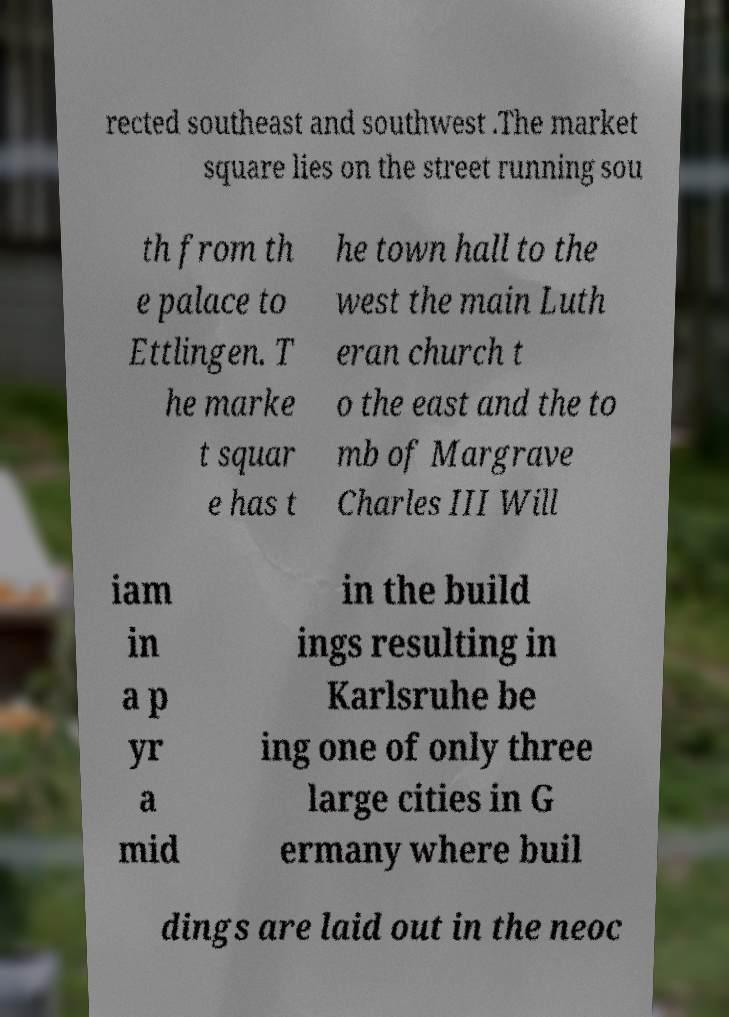Please read and relay the text visible in this image. What does it say? rected southeast and southwest .The market square lies on the street running sou th from th e palace to Ettlingen. T he marke t squar e has t he town hall to the west the main Luth eran church t o the east and the to mb of Margrave Charles III Will iam in a p yr a mid in the build ings resulting in Karlsruhe be ing one of only three large cities in G ermany where buil dings are laid out in the neoc 